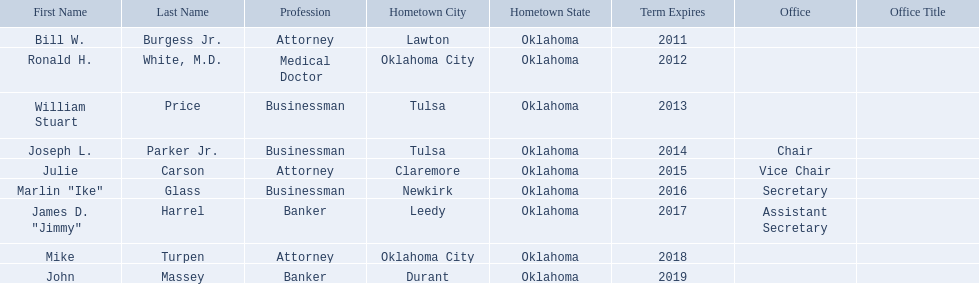What are all the names of oklahoma state regents for higher educations? Bill W. Burgess Jr., Ronald H. White, M.D., William Stuart Price, Joseph L. Parker Jr., Julie Carson, Marlin "Ike" Glass, James D. "Jimmy" Harrel, Mike Turpen, John Massey. Which ones are businessmen? William Stuart Price, Joseph L. Parker Jr., Marlin "Ike" Glass. Of those, who is from tulsa? William Stuart Price, Joseph L. Parker Jr. Whose term expires in 2014? Joseph L. Parker Jr. 